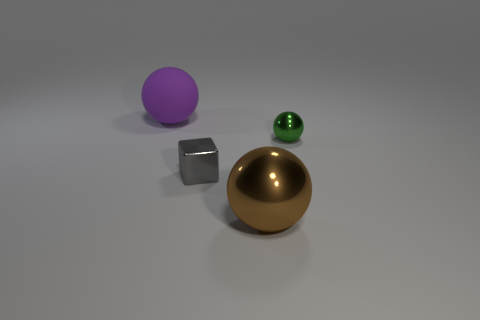There is a metallic ball that is behind the large brown sphere; what number of green shiny balls are left of it?
Offer a terse response. 0. What is the shape of the brown thing?
Ensure brevity in your answer.  Sphere. There is a big thing that is made of the same material as the small green object; what is its shape?
Keep it short and to the point. Sphere. Does the small thing right of the block have the same shape as the purple thing?
Ensure brevity in your answer.  Yes. What is the shape of the tiny metal thing that is in front of the green metallic thing?
Your response must be concise. Cube. What number of blocks have the same size as the purple rubber ball?
Offer a very short reply. 0. The big rubber ball has what color?
Provide a succinct answer. Purple. Does the large metal object have the same color as the small object that is left of the tiny green object?
Provide a succinct answer. No. What size is the other ball that is the same material as the small green ball?
Your response must be concise. Large. Are there any things that have the same color as the block?
Your response must be concise. No. 